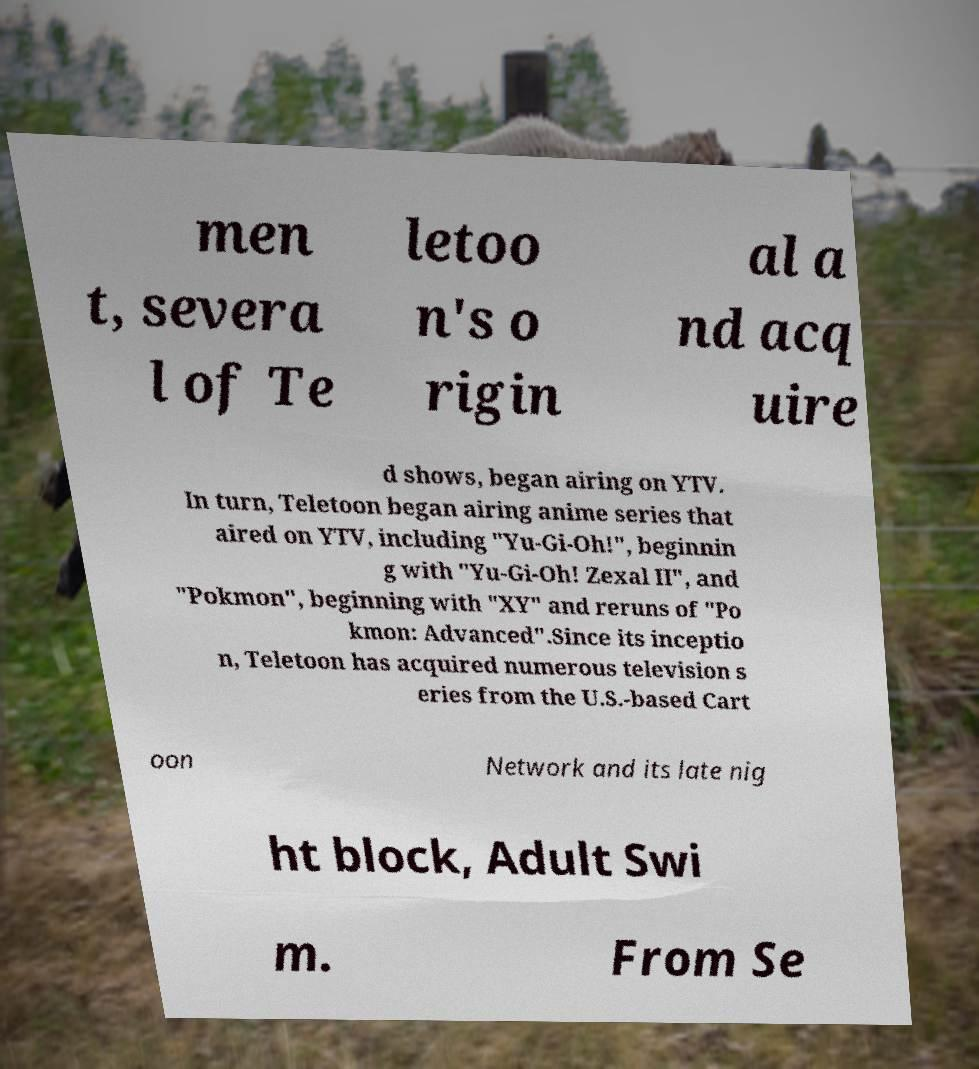What messages or text are displayed in this image? I need them in a readable, typed format. men t, severa l of Te letoo n's o rigin al a nd acq uire d shows, began airing on YTV. In turn, Teletoon began airing anime series that aired on YTV, including "Yu-Gi-Oh!", beginnin g with "Yu-Gi-Oh! Zexal II", and "Pokmon", beginning with "XY" and reruns of "Po kmon: Advanced".Since its inceptio n, Teletoon has acquired numerous television s eries from the U.S.-based Cart oon Network and its late nig ht block, Adult Swi m. From Se 